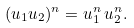<formula> <loc_0><loc_0><loc_500><loc_500>( u _ { 1 } u _ { 2 } ) ^ { n } = u _ { 1 } ^ { n } \, u _ { 2 } ^ { n } .</formula> 